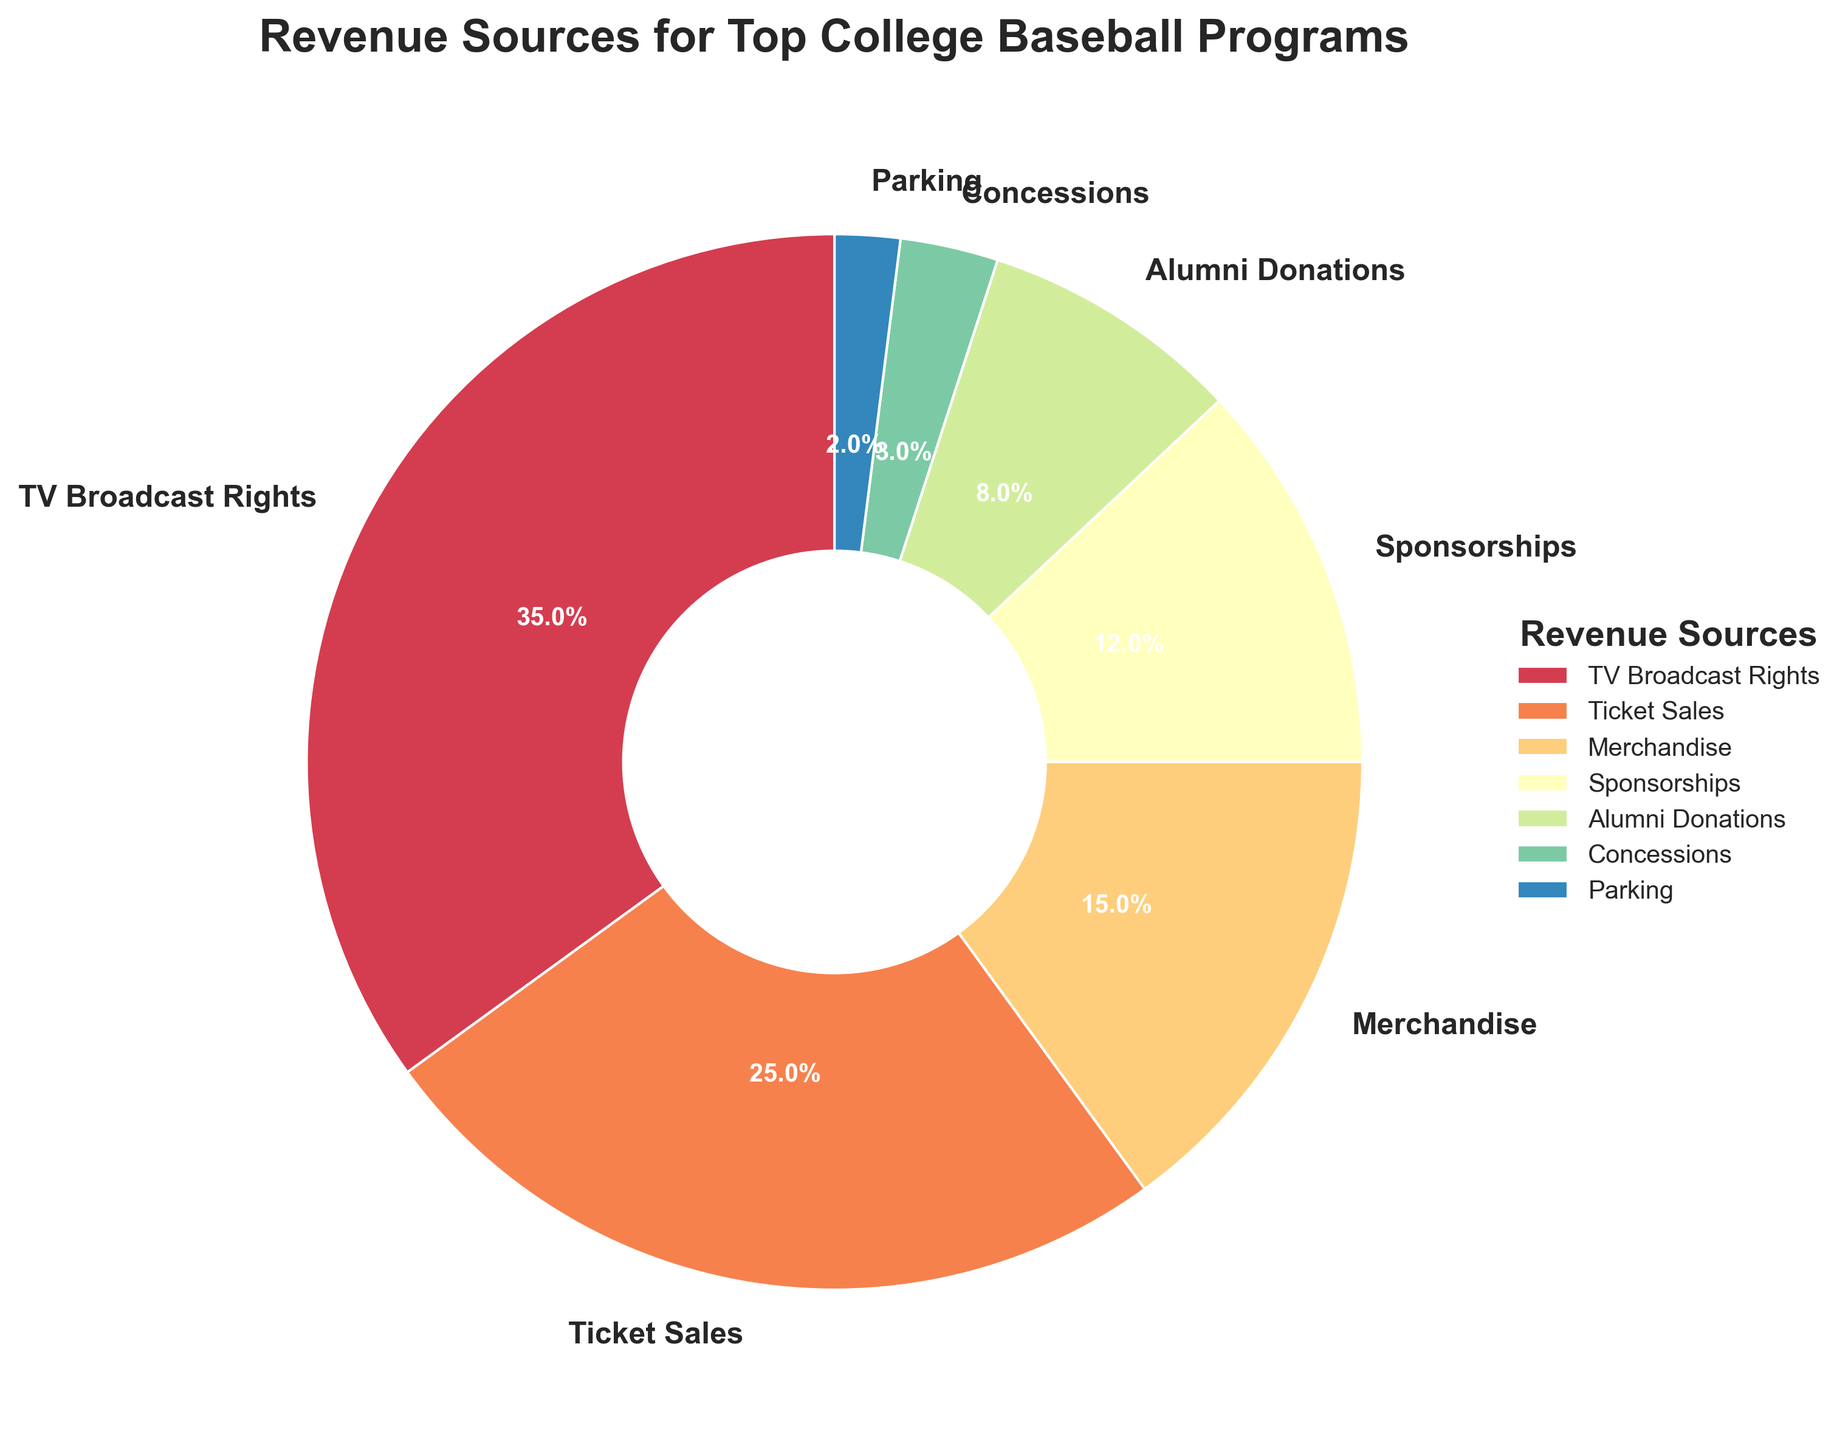Which revenue source brings in the highest percentage? Looking at the pie chart, the largest segment is labeled "TV Broadcast Rights" which has the highest percentage.
Answer: TV Broadcast Rights Which revenue source has the smallest contribution to the total revenue? The smallest segment in the pie chart is labeled "Parking" with a 2% contribution.
Answer: Parking What is the combined revenue percentage from Sponsorships and Merchandise? The percentage for Sponsorships is 12%, and for Merchandise is 15%. Adding these together gives 12% + 15% = 27%.
Answer: 27% How does the percentage of Ticket Sales compare to Alumni Donations? Ticket Sales have a percentage of 25%, while Alumni Donations have 8%. Comparing these, Ticket Sales are greater than Alumni Donations.
Answer: Ticket Sales are greater What percentage of the total revenue comes from non-ticket related sources? Non-ticket related sources include TV Broadcast Rights (35%), Merchandise (15%), Sponsorships (12%), Alumni Donations (8%), Concessions (3%), and Parking (2%). Adding these together gives 35% + 15% + 12% + 8% + 3% + 2% = 75%.
Answer: 75% Visually, which revenue source is represented by the second largest segment in the pie chart? The second largest segment in the pie chart is labeled "Ticket Sales" with a 25% contribution.
Answer: Ticket Sales What is the difference between the revenue percentage of TV Broadcast Rights and Sponsorships? TV Broadcast Rights have a percentage of 35%, and Sponsorships have 12%. The difference is 35% - 12% = 23%.
Answer: 23% If you combine the percentages of Concessions and Parking, how does it compare to Alumni Donations? The combined percentage of Concessions (3%) and Parking (2%) is 3% + 2% = 5%. This is less than the percentage for Alumni Donations, which is 8%.
Answer: Less than Alumni Donations 